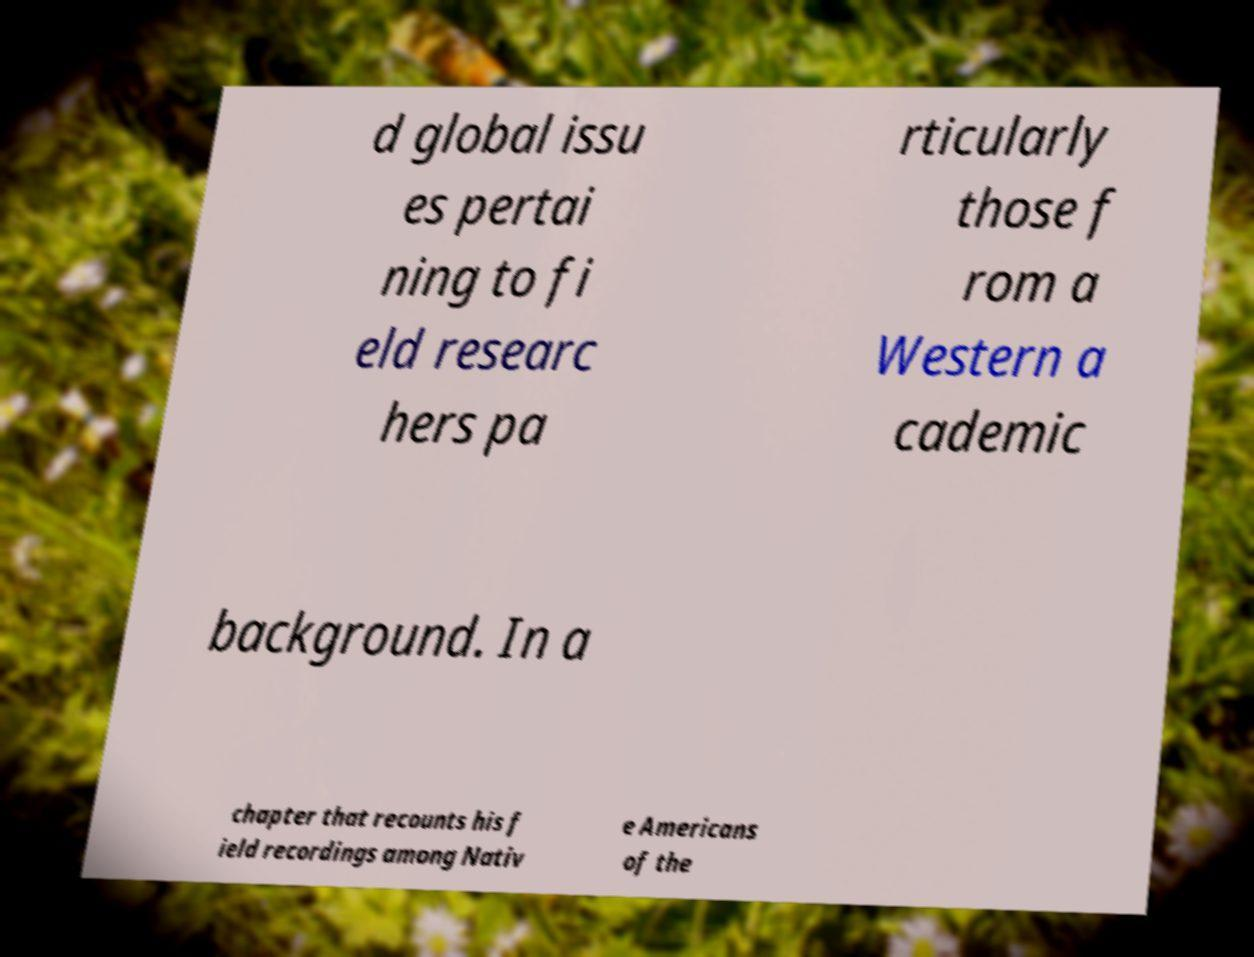Can you accurately transcribe the text from the provided image for me? d global issu es pertai ning to fi eld researc hers pa rticularly those f rom a Western a cademic background. In a chapter that recounts his f ield recordings among Nativ e Americans of the 